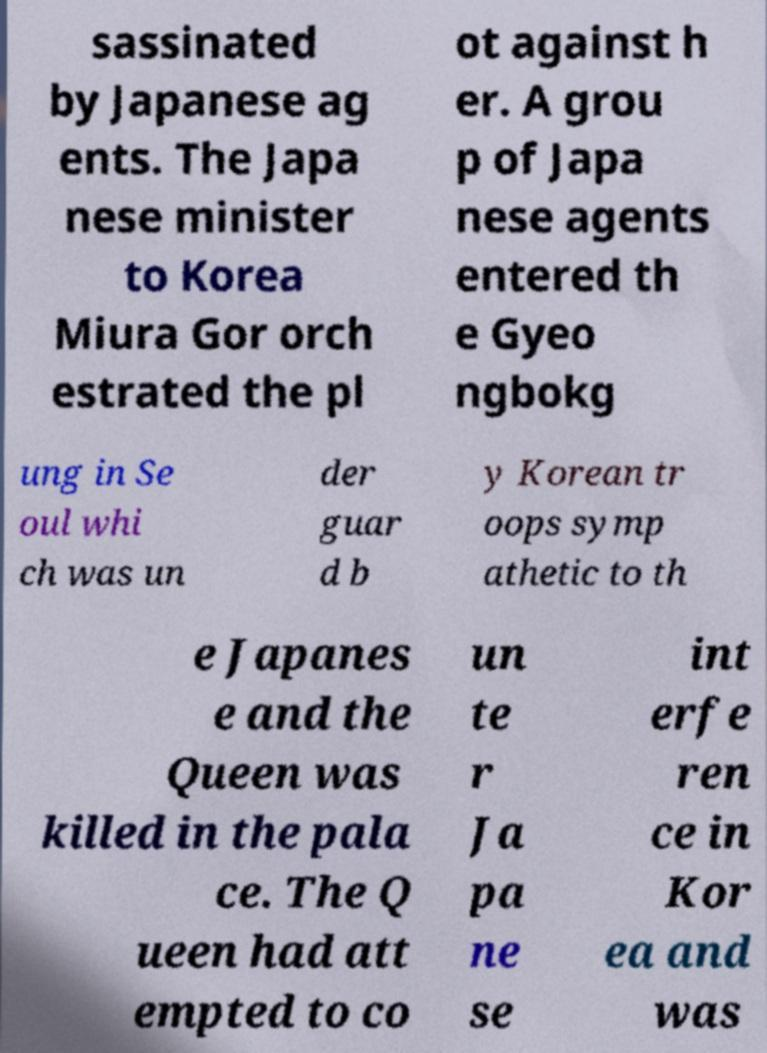Can you accurately transcribe the text from the provided image for me? sassinated by Japanese ag ents. The Japa nese minister to Korea Miura Gor orch estrated the pl ot against h er. A grou p of Japa nese agents entered th e Gyeo ngbokg ung in Se oul whi ch was un der guar d b y Korean tr oops symp athetic to th e Japanes e and the Queen was killed in the pala ce. The Q ueen had att empted to co un te r Ja pa ne se int erfe ren ce in Kor ea and was 